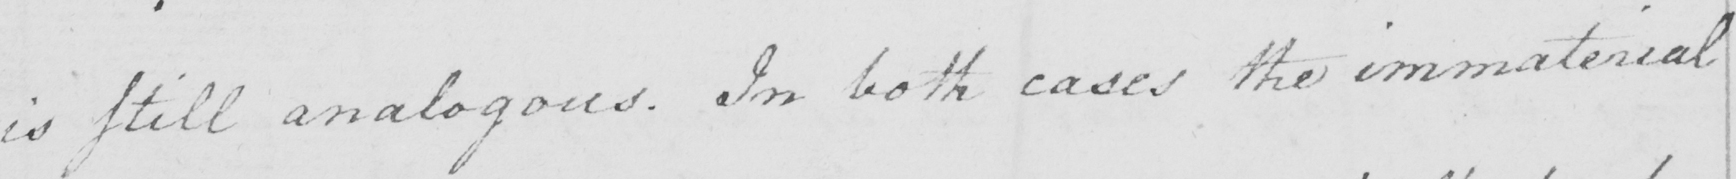Can you read and transcribe this handwriting? is still analogous . In both cases the immaterial 